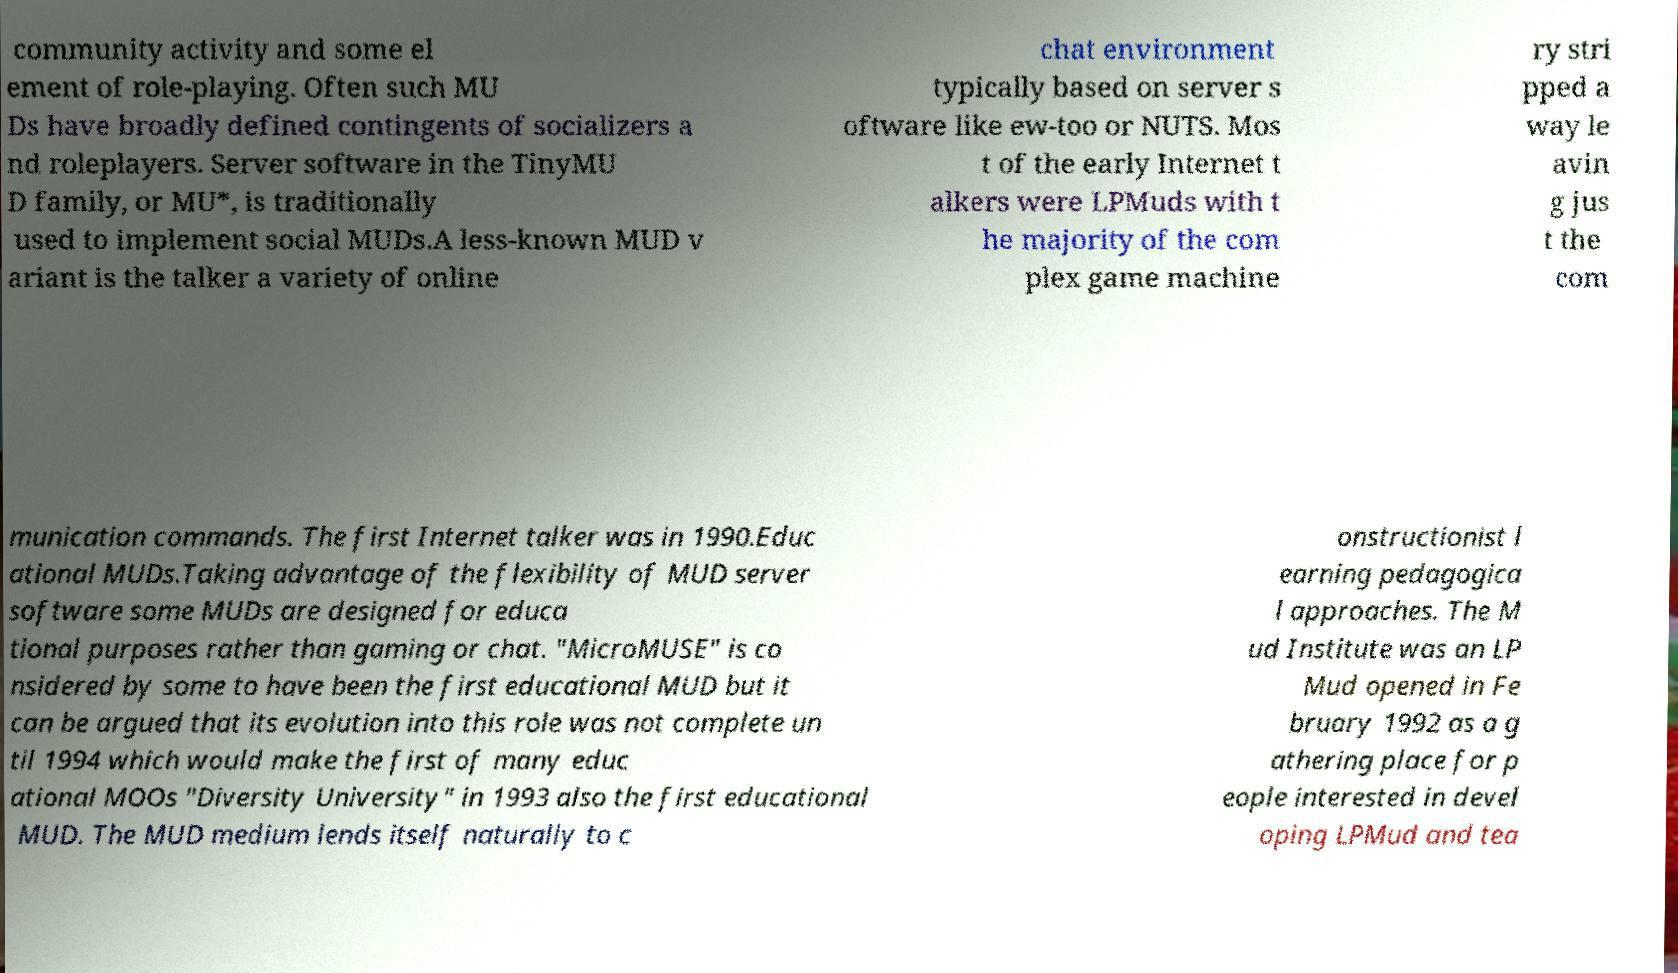For documentation purposes, I need the text within this image transcribed. Could you provide that? community activity and some el ement of role-playing. Often such MU Ds have broadly defined contingents of socializers a nd roleplayers. Server software in the TinyMU D family, or MU*, is traditionally used to implement social MUDs.A less-known MUD v ariant is the talker a variety of online chat environment typically based on server s oftware like ew-too or NUTS. Mos t of the early Internet t alkers were LPMuds with t he majority of the com plex game machine ry stri pped a way le avin g jus t the com munication commands. The first Internet talker was in 1990.Educ ational MUDs.Taking advantage of the flexibility of MUD server software some MUDs are designed for educa tional purposes rather than gaming or chat. "MicroMUSE" is co nsidered by some to have been the first educational MUD but it can be argued that its evolution into this role was not complete un til 1994 which would make the first of many educ ational MOOs "Diversity University" in 1993 also the first educational MUD. The MUD medium lends itself naturally to c onstructionist l earning pedagogica l approaches. The M ud Institute was an LP Mud opened in Fe bruary 1992 as a g athering place for p eople interested in devel oping LPMud and tea 